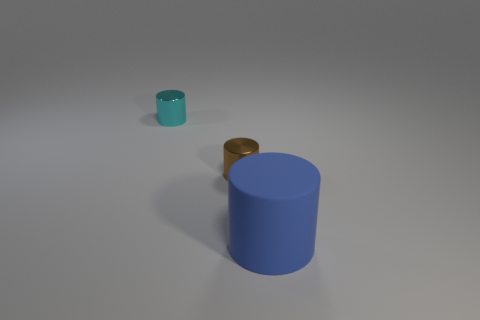Is there anything else that has the same size as the matte thing?
Ensure brevity in your answer.  No. There is another thing that is the same material as the small brown object; what is its size?
Your answer should be compact. Small. How many cyan objects are either metallic objects or matte things?
Your answer should be very brief. 1. Are there any other things that have the same material as the large blue thing?
Give a very brief answer. No. How many yellow rubber blocks are there?
Your answer should be compact. 0. What is the shape of the other object that is the same material as the tiny brown thing?
Give a very brief answer. Cylinder. There is a matte cylinder; is its color the same as the metal cylinder that is in front of the small cyan shiny cylinder?
Ensure brevity in your answer.  No. Are there fewer blue cylinders that are left of the big blue thing than gray metal cylinders?
Provide a succinct answer. No. There is a object behind the tiny brown object; what material is it?
Your response must be concise. Metal. What number of other objects are the same size as the cyan shiny cylinder?
Your answer should be very brief. 1. 